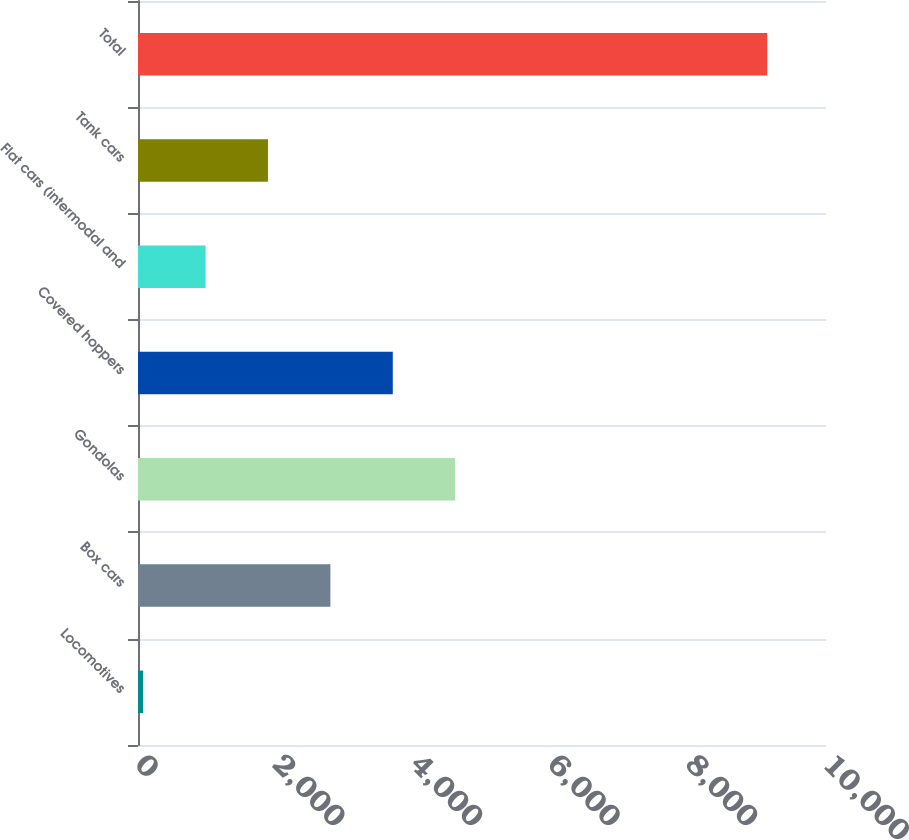<chart> <loc_0><loc_0><loc_500><loc_500><bar_chart><fcel>Locomotives<fcel>Box cars<fcel>Gondolas<fcel>Covered hoppers<fcel>Flat cars (intermodal and<fcel>Tank cars<fcel>Total<nl><fcel>75<fcel>2796.3<fcel>4610.5<fcel>3703.4<fcel>982.1<fcel>1889.2<fcel>9146<nl></chart> 